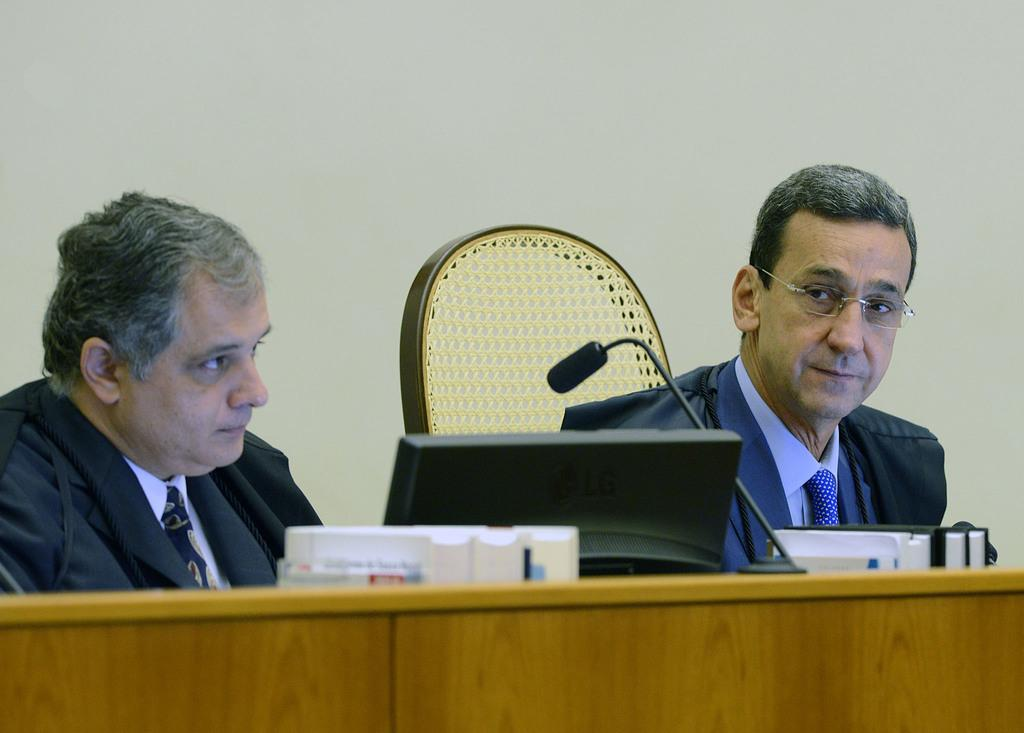How many people are in the image? There are two men in the image. What are the men doing in the image? The men are sitting in chairs. What is on the table in front of the men? There is a mic, a desktop, and books on the table. What can be seen in the background of the image? There is a wall in the background of the image. What type of owl can be seen sitting on the desktop in the image? There is no owl present on the desktop or in the image. How does the stomach of one of the men look in the image? There is no information about the men's stomachs in the image. 